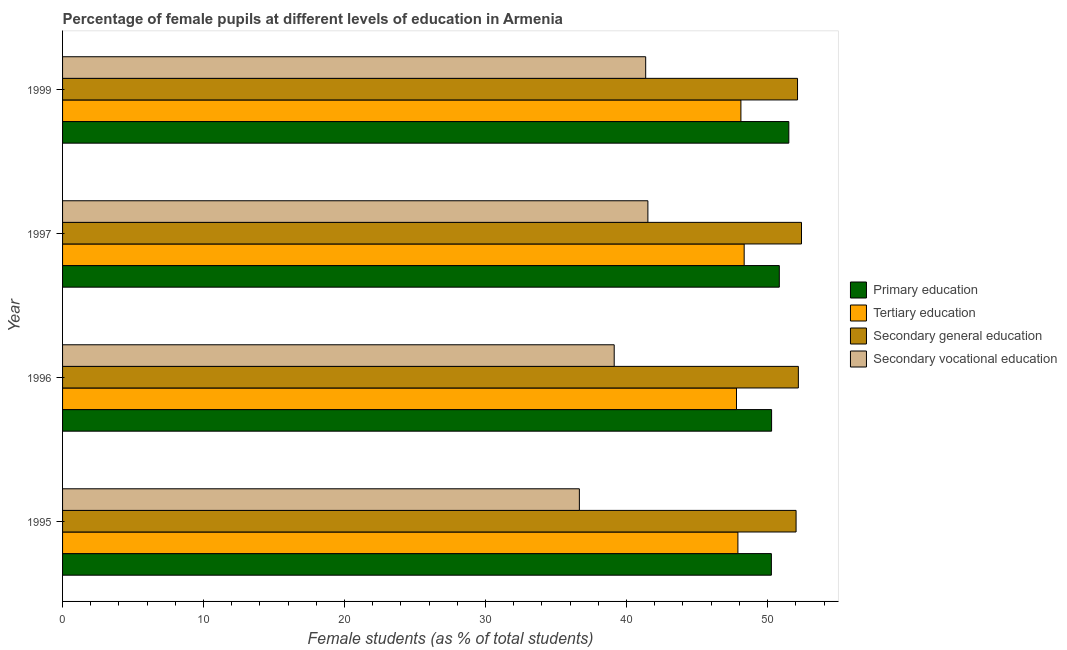How many groups of bars are there?
Your answer should be compact. 4. Are the number of bars on each tick of the Y-axis equal?
Provide a succinct answer. Yes. How many bars are there on the 4th tick from the top?
Provide a succinct answer. 4. What is the label of the 2nd group of bars from the top?
Give a very brief answer. 1997. What is the percentage of female students in secondary education in 1999?
Your answer should be very brief. 52.12. Across all years, what is the maximum percentage of female students in secondary vocational education?
Provide a succinct answer. 41.51. Across all years, what is the minimum percentage of female students in secondary vocational education?
Your answer should be very brief. 36.65. What is the total percentage of female students in tertiary education in the graph?
Make the answer very short. 192.14. What is the difference between the percentage of female students in tertiary education in 1996 and that in 1997?
Offer a very short reply. -0.54. What is the difference between the percentage of female students in tertiary education in 1997 and the percentage of female students in primary education in 1996?
Provide a succinct answer. -1.94. What is the average percentage of female students in secondary education per year?
Your response must be concise. 52.18. In the year 1999, what is the difference between the percentage of female students in primary education and percentage of female students in tertiary education?
Make the answer very short. 3.4. In how many years, is the percentage of female students in tertiary education greater than 22 %?
Keep it short and to the point. 4. What is the ratio of the percentage of female students in primary education in 1996 to that in 1999?
Keep it short and to the point. 0.98. What is the difference between the highest and the second highest percentage of female students in tertiary education?
Ensure brevity in your answer.  0.23. What is the difference between the highest and the lowest percentage of female students in secondary education?
Provide a short and direct response. 0.38. Is the sum of the percentage of female students in secondary education in 1995 and 1996 greater than the maximum percentage of female students in secondary vocational education across all years?
Make the answer very short. Yes. What does the 1st bar from the top in 1996 represents?
Keep it short and to the point. Secondary vocational education. What does the 3rd bar from the bottom in 1999 represents?
Give a very brief answer. Secondary general education. Where does the legend appear in the graph?
Make the answer very short. Center right. How many legend labels are there?
Offer a very short reply. 4. What is the title of the graph?
Offer a very short reply. Percentage of female pupils at different levels of education in Armenia. Does "UNAIDS" appear as one of the legend labels in the graph?
Provide a short and direct response. No. What is the label or title of the X-axis?
Offer a terse response. Female students (as % of total students). What is the Female students (as % of total students) of Primary education in 1995?
Make the answer very short. 50.27. What is the Female students (as % of total students) of Tertiary education in 1995?
Ensure brevity in your answer.  47.89. What is the Female students (as % of total students) of Secondary general education in 1995?
Keep it short and to the point. 52.02. What is the Female students (as % of total students) of Secondary vocational education in 1995?
Provide a short and direct response. 36.65. What is the Female students (as % of total students) of Primary education in 1996?
Offer a very short reply. 50.28. What is the Female students (as % of total students) in Tertiary education in 1996?
Offer a terse response. 47.79. What is the Female students (as % of total students) in Secondary general education in 1996?
Offer a terse response. 52.18. What is the Female students (as % of total students) in Secondary vocational education in 1996?
Ensure brevity in your answer.  39.12. What is the Female students (as % of total students) of Primary education in 1997?
Your answer should be compact. 50.83. What is the Female students (as % of total students) of Tertiary education in 1997?
Provide a succinct answer. 48.34. What is the Female students (as % of total students) of Secondary general education in 1997?
Provide a short and direct response. 52.4. What is the Female students (as % of total students) of Secondary vocational education in 1997?
Give a very brief answer. 41.51. What is the Female students (as % of total students) of Primary education in 1999?
Your answer should be compact. 51.51. What is the Female students (as % of total students) of Tertiary education in 1999?
Offer a terse response. 48.11. What is the Female students (as % of total students) of Secondary general education in 1999?
Your answer should be very brief. 52.12. What is the Female students (as % of total students) in Secondary vocational education in 1999?
Offer a very short reply. 41.35. Across all years, what is the maximum Female students (as % of total students) in Primary education?
Your answer should be compact. 51.51. Across all years, what is the maximum Female students (as % of total students) of Tertiary education?
Your answer should be very brief. 48.34. Across all years, what is the maximum Female students (as % of total students) of Secondary general education?
Your response must be concise. 52.4. Across all years, what is the maximum Female students (as % of total students) in Secondary vocational education?
Your answer should be compact. 41.51. Across all years, what is the minimum Female students (as % of total students) of Primary education?
Your answer should be very brief. 50.27. Across all years, what is the minimum Female students (as % of total students) in Tertiary education?
Provide a succinct answer. 47.79. Across all years, what is the minimum Female students (as % of total students) in Secondary general education?
Provide a short and direct response. 52.02. Across all years, what is the minimum Female students (as % of total students) of Secondary vocational education?
Your answer should be compact. 36.65. What is the total Female students (as % of total students) in Primary education in the graph?
Keep it short and to the point. 202.89. What is the total Female students (as % of total students) in Tertiary education in the graph?
Offer a terse response. 192.14. What is the total Female students (as % of total students) in Secondary general education in the graph?
Ensure brevity in your answer.  208.73. What is the total Female students (as % of total students) of Secondary vocational education in the graph?
Provide a succinct answer. 158.64. What is the difference between the Female students (as % of total students) of Primary education in 1995 and that in 1996?
Offer a very short reply. -0.02. What is the difference between the Female students (as % of total students) of Tertiary education in 1995 and that in 1996?
Provide a short and direct response. 0.1. What is the difference between the Female students (as % of total students) in Secondary general education in 1995 and that in 1996?
Offer a terse response. -0.16. What is the difference between the Female students (as % of total students) in Secondary vocational education in 1995 and that in 1996?
Provide a short and direct response. -2.47. What is the difference between the Female students (as % of total students) in Primary education in 1995 and that in 1997?
Keep it short and to the point. -0.56. What is the difference between the Female students (as % of total students) of Tertiary education in 1995 and that in 1997?
Offer a terse response. -0.44. What is the difference between the Female students (as % of total students) of Secondary general education in 1995 and that in 1997?
Your answer should be compact. -0.38. What is the difference between the Female students (as % of total students) of Secondary vocational education in 1995 and that in 1997?
Provide a succinct answer. -4.86. What is the difference between the Female students (as % of total students) in Primary education in 1995 and that in 1999?
Your answer should be very brief. -1.24. What is the difference between the Female students (as % of total students) in Tertiary education in 1995 and that in 1999?
Your answer should be compact. -0.21. What is the difference between the Female students (as % of total students) in Secondary general education in 1995 and that in 1999?
Provide a succinct answer. -0.1. What is the difference between the Female students (as % of total students) of Secondary vocational education in 1995 and that in 1999?
Provide a succinct answer. -4.7. What is the difference between the Female students (as % of total students) of Primary education in 1996 and that in 1997?
Give a very brief answer. -0.55. What is the difference between the Female students (as % of total students) in Tertiary education in 1996 and that in 1997?
Your answer should be very brief. -0.54. What is the difference between the Female students (as % of total students) in Secondary general education in 1996 and that in 1997?
Offer a very short reply. -0.22. What is the difference between the Female students (as % of total students) of Secondary vocational education in 1996 and that in 1997?
Offer a terse response. -2.39. What is the difference between the Female students (as % of total students) of Primary education in 1996 and that in 1999?
Make the answer very short. -1.22. What is the difference between the Female students (as % of total students) of Tertiary education in 1996 and that in 1999?
Offer a terse response. -0.31. What is the difference between the Female students (as % of total students) in Secondary general education in 1996 and that in 1999?
Offer a terse response. 0.06. What is the difference between the Female students (as % of total students) of Secondary vocational education in 1996 and that in 1999?
Offer a very short reply. -2.23. What is the difference between the Female students (as % of total students) in Primary education in 1997 and that in 1999?
Provide a succinct answer. -0.68. What is the difference between the Female students (as % of total students) of Tertiary education in 1997 and that in 1999?
Give a very brief answer. 0.23. What is the difference between the Female students (as % of total students) in Secondary general education in 1997 and that in 1999?
Offer a terse response. 0.28. What is the difference between the Female students (as % of total students) in Secondary vocational education in 1997 and that in 1999?
Keep it short and to the point. 0.16. What is the difference between the Female students (as % of total students) in Primary education in 1995 and the Female students (as % of total students) in Tertiary education in 1996?
Make the answer very short. 2.47. What is the difference between the Female students (as % of total students) of Primary education in 1995 and the Female students (as % of total students) of Secondary general education in 1996?
Your answer should be compact. -1.91. What is the difference between the Female students (as % of total students) of Primary education in 1995 and the Female students (as % of total students) of Secondary vocational education in 1996?
Your answer should be compact. 11.15. What is the difference between the Female students (as % of total students) of Tertiary education in 1995 and the Female students (as % of total students) of Secondary general education in 1996?
Provide a succinct answer. -4.29. What is the difference between the Female students (as % of total students) in Tertiary education in 1995 and the Female students (as % of total students) in Secondary vocational education in 1996?
Ensure brevity in your answer.  8.77. What is the difference between the Female students (as % of total students) of Secondary general education in 1995 and the Female students (as % of total students) of Secondary vocational education in 1996?
Ensure brevity in your answer.  12.9. What is the difference between the Female students (as % of total students) of Primary education in 1995 and the Female students (as % of total students) of Tertiary education in 1997?
Give a very brief answer. 1.93. What is the difference between the Female students (as % of total students) of Primary education in 1995 and the Female students (as % of total students) of Secondary general education in 1997?
Provide a succinct answer. -2.14. What is the difference between the Female students (as % of total students) in Primary education in 1995 and the Female students (as % of total students) in Secondary vocational education in 1997?
Your answer should be compact. 8.76. What is the difference between the Female students (as % of total students) of Tertiary education in 1995 and the Female students (as % of total students) of Secondary general education in 1997?
Give a very brief answer. -4.51. What is the difference between the Female students (as % of total students) of Tertiary education in 1995 and the Female students (as % of total students) of Secondary vocational education in 1997?
Your response must be concise. 6.38. What is the difference between the Female students (as % of total students) of Secondary general education in 1995 and the Female students (as % of total students) of Secondary vocational education in 1997?
Provide a succinct answer. 10.51. What is the difference between the Female students (as % of total students) of Primary education in 1995 and the Female students (as % of total students) of Tertiary education in 1999?
Provide a short and direct response. 2.16. What is the difference between the Female students (as % of total students) in Primary education in 1995 and the Female students (as % of total students) in Secondary general education in 1999?
Give a very brief answer. -1.85. What is the difference between the Female students (as % of total students) of Primary education in 1995 and the Female students (as % of total students) of Secondary vocational education in 1999?
Your answer should be compact. 8.91. What is the difference between the Female students (as % of total students) in Tertiary education in 1995 and the Female students (as % of total students) in Secondary general education in 1999?
Make the answer very short. -4.23. What is the difference between the Female students (as % of total students) in Tertiary education in 1995 and the Female students (as % of total students) in Secondary vocational education in 1999?
Give a very brief answer. 6.54. What is the difference between the Female students (as % of total students) of Secondary general education in 1995 and the Female students (as % of total students) of Secondary vocational education in 1999?
Ensure brevity in your answer.  10.67. What is the difference between the Female students (as % of total students) in Primary education in 1996 and the Female students (as % of total students) in Tertiary education in 1997?
Provide a short and direct response. 1.94. What is the difference between the Female students (as % of total students) of Primary education in 1996 and the Female students (as % of total students) of Secondary general education in 1997?
Keep it short and to the point. -2.12. What is the difference between the Female students (as % of total students) in Primary education in 1996 and the Female students (as % of total students) in Secondary vocational education in 1997?
Give a very brief answer. 8.77. What is the difference between the Female students (as % of total students) of Tertiary education in 1996 and the Female students (as % of total students) of Secondary general education in 1997?
Offer a very short reply. -4.61. What is the difference between the Female students (as % of total students) of Tertiary education in 1996 and the Female students (as % of total students) of Secondary vocational education in 1997?
Offer a very short reply. 6.28. What is the difference between the Female students (as % of total students) of Secondary general education in 1996 and the Female students (as % of total students) of Secondary vocational education in 1997?
Your answer should be compact. 10.67. What is the difference between the Female students (as % of total students) in Primary education in 1996 and the Female students (as % of total students) in Tertiary education in 1999?
Your answer should be compact. 2.18. What is the difference between the Female students (as % of total students) of Primary education in 1996 and the Female students (as % of total students) of Secondary general education in 1999?
Offer a terse response. -1.84. What is the difference between the Female students (as % of total students) in Primary education in 1996 and the Female students (as % of total students) in Secondary vocational education in 1999?
Your response must be concise. 8.93. What is the difference between the Female students (as % of total students) of Tertiary education in 1996 and the Female students (as % of total students) of Secondary general education in 1999?
Your answer should be very brief. -4.33. What is the difference between the Female students (as % of total students) in Tertiary education in 1996 and the Female students (as % of total students) in Secondary vocational education in 1999?
Keep it short and to the point. 6.44. What is the difference between the Female students (as % of total students) in Secondary general education in 1996 and the Female students (as % of total students) in Secondary vocational education in 1999?
Offer a terse response. 10.83. What is the difference between the Female students (as % of total students) in Primary education in 1997 and the Female students (as % of total students) in Tertiary education in 1999?
Offer a terse response. 2.72. What is the difference between the Female students (as % of total students) in Primary education in 1997 and the Female students (as % of total students) in Secondary general education in 1999?
Provide a succinct answer. -1.29. What is the difference between the Female students (as % of total students) in Primary education in 1997 and the Female students (as % of total students) in Secondary vocational education in 1999?
Give a very brief answer. 9.48. What is the difference between the Female students (as % of total students) in Tertiary education in 1997 and the Female students (as % of total students) in Secondary general education in 1999?
Offer a terse response. -3.78. What is the difference between the Female students (as % of total students) in Tertiary education in 1997 and the Female students (as % of total students) in Secondary vocational education in 1999?
Your answer should be very brief. 6.99. What is the difference between the Female students (as % of total students) of Secondary general education in 1997 and the Female students (as % of total students) of Secondary vocational education in 1999?
Give a very brief answer. 11.05. What is the average Female students (as % of total students) in Primary education per year?
Offer a very short reply. 50.72. What is the average Female students (as % of total students) of Tertiary education per year?
Provide a succinct answer. 48.03. What is the average Female students (as % of total students) of Secondary general education per year?
Provide a short and direct response. 52.18. What is the average Female students (as % of total students) of Secondary vocational education per year?
Provide a short and direct response. 39.66. In the year 1995, what is the difference between the Female students (as % of total students) in Primary education and Female students (as % of total students) in Tertiary education?
Offer a terse response. 2.37. In the year 1995, what is the difference between the Female students (as % of total students) in Primary education and Female students (as % of total students) in Secondary general education?
Your response must be concise. -1.75. In the year 1995, what is the difference between the Female students (as % of total students) in Primary education and Female students (as % of total students) in Secondary vocational education?
Provide a short and direct response. 13.62. In the year 1995, what is the difference between the Female students (as % of total students) in Tertiary education and Female students (as % of total students) in Secondary general education?
Provide a short and direct response. -4.13. In the year 1995, what is the difference between the Female students (as % of total students) in Tertiary education and Female students (as % of total students) in Secondary vocational education?
Provide a succinct answer. 11.24. In the year 1995, what is the difference between the Female students (as % of total students) of Secondary general education and Female students (as % of total students) of Secondary vocational education?
Offer a very short reply. 15.37. In the year 1996, what is the difference between the Female students (as % of total students) of Primary education and Female students (as % of total students) of Tertiary education?
Offer a terse response. 2.49. In the year 1996, what is the difference between the Female students (as % of total students) of Primary education and Female students (as % of total students) of Secondary general education?
Offer a terse response. -1.9. In the year 1996, what is the difference between the Female students (as % of total students) in Primary education and Female students (as % of total students) in Secondary vocational education?
Offer a very short reply. 11.16. In the year 1996, what is the difference between the Female students (as % of total students) of Tertiary education and Female students (as % of total students) of Secondary general education?
Your answer should be very brief. -4.39. In the year 1996, what is the difference between the Female students (as % of total students) in Tertiary education and Female students (as % of total students) in Secondary vocational education?
Your response must be concise. 8.67. In the year 1996, what is the difference between the Female students (as % of total students) in Secondary general education and Female students (as % of total students) in Secondary vocational education?
Your answer should be compact. 13.06. In the year 1997, what is the difference between the Female students (as % of total students) in Primary education and Female students (as % of total students) in Tertiary education?
Give a very brief answer. 2.49. In the year 1997, what is the difference between the Female students (as % of total students) of Primary education and Female students (as % of total students) of Secondary general education?
Make the answer very short. -1.57. In the year 1997, what is the difference between the Female students (as % of total students) of Primary education and Female students (as % of total students) of Secondary vocational education?
Provide a succinct answer. 9.32. In the year 1997, what is the difference between the Female students (as % of total students) in Tertiary education and Female students (as % of total students) in Secondary general education?
Offer a very short reply. -4.07. In the year 1997, what is the difference between the Female students (as % of total students) of Tertiary education and Female students (as % of total students) of Secondary vocational education?
Your answer should be very brief. 6.83. In the year 1997, what is the difference between the Female students (as % of total students) in Secondary general education and Female students (as % of total students) in Secondary vocational education?
Give a very brief answer. 10.89. In the year 1999, what is the difference between the Female students (as % of total students) of Primary education and Female students (as % of total students) of Tertiary education?
Keep it short and to the point. 3.4. In the year 1999, what is the difference between the Female students (as % of total students) in Primary education and Female students (as % of total students) in Secondary general education?
Offer a terse response. -0.62. In the year 1999, what is the difference between the Female students (as % of total students) in Primary education and Female students (as % of total students) in Secondary vocational education?
Your answer should be compact. 10.15. In the year 1999, what is the difference between the Female students (as % of total students) in Tertiary education and Female students (as % of total students) in Secondary general education?
Provide a succinct answer. -4.02. In the year 1999, what is the difference between the Female students (as % of total students) in Tertiary education and Female students (as % of total students) in Secondary vocational education?
Offer a terse response. 6.75. In the year 1999, what is the difference between the Female students (as % of total students) in Secondary general education and Female students (as % of total students) in Secondary vocational education?
Your answer should be very brief. 10.77. What is the ratio of the Female students (as % of total students) in Secondary vocational education in 1995 to that in 1996?
Your answer should be compact. 0.94. What is the ratio of the Female students (as % of total students) of Primary education in 1995 to that in 1997?
Your answer should be very brief. 0.99. What is the ratio of the Female students (as % of total students) of Tertiary education in 1995 to that in 1997?
Provide a short and direct response. 0.99. What is the ratio of the Female students (as % of total students) in Secondary general education in 1995 to that in 1997?
Your answer should be very brief. 0.99. What is the ratio of the Female students (as % of total students) in Secondary vocational education in 1995 to that in 1997?
Your answer should be very brief. 0.88. What is the ratio of the Female students (as % of total students) of Secondary general education in 1995 to that in 1999?
Your answer should be compact. 1. What is the ratio of the Female students (as % of total students) in Secondary vocational education in 1995 to that in 1999?
Your answer should be very brief. 0.89. What is the ratio of the Female students (as % of total students) of Primary education in 1996 to that in 1997?
Offer a terse response. 0.99. What is the ratio of the Female students (as % of total students) in Tertiary education in 1996 to that in 1997?
Make the answer very short. 0.99. What is the ratio of the Female students (as % of total students) of Secondary vocational education in 1996 to that in 1997?
Offer a very short reply. 0.94. What is the ratio of the Female students (as % of total students) in Primary education in 1996 to that in 1999?
Provide a succinct answer. 0.98. What is the ratio of the Female students (as % of total students) in Secondary vocational education in 1996 to that in 1999?
Offer a terse response. 0.95. What is the ratio of the Female students (as % of total students) of Primary education in 1997 to that in 1999?
Provide a short and direct response. 0.99. What is the ratio of the Female students (as % of total students) of Tertiary education in 1997 to that in 1999?
Offer a terse response. 1. What is the ratio of the Female students (as % of total students) of Secondary general education in 1997 to that in 1999?
Offer a terse response. 1.01. What is the ratio of the Female students (as % of total students) of Secondary vocational education in 1997 to that in 1999?
Provide a succinct answer. 1. What is the difference between the highest and the second highest Female students (as % of total students) in Primary education?
Offer a terse response. 0.68. What is the difference between the highest and the second highest Female students (as % of total students) in Tertiary education?
Make the answer very short. 0.23. What is the difference between the highest and the second highest Female students (as % of total students) in Secondary general education?
Ensure brevity in your answer.  0.22. What is the difference between the highest and the second highest Female students (as % of total students) in Secondary vocational education?
Offer a terse response. 0.16. What is the difference between the highest and the lowest Female students (as % of total students) of Primary education?
Offer a terse response. 1.24. What is the difference between the highest and the lowest Female students (as % of total students) in Tertiary education?
Provide a succinct answer. 0.54. What is the difference between the highest and the lowest Female students (as % of total students) of Secondary general education?
Offer a very short reply. 0.38. What is the difference between the highest and the lowest Female students (as % of total students) of Secondary vocational education?
Offer a very short reply. 4.86. 